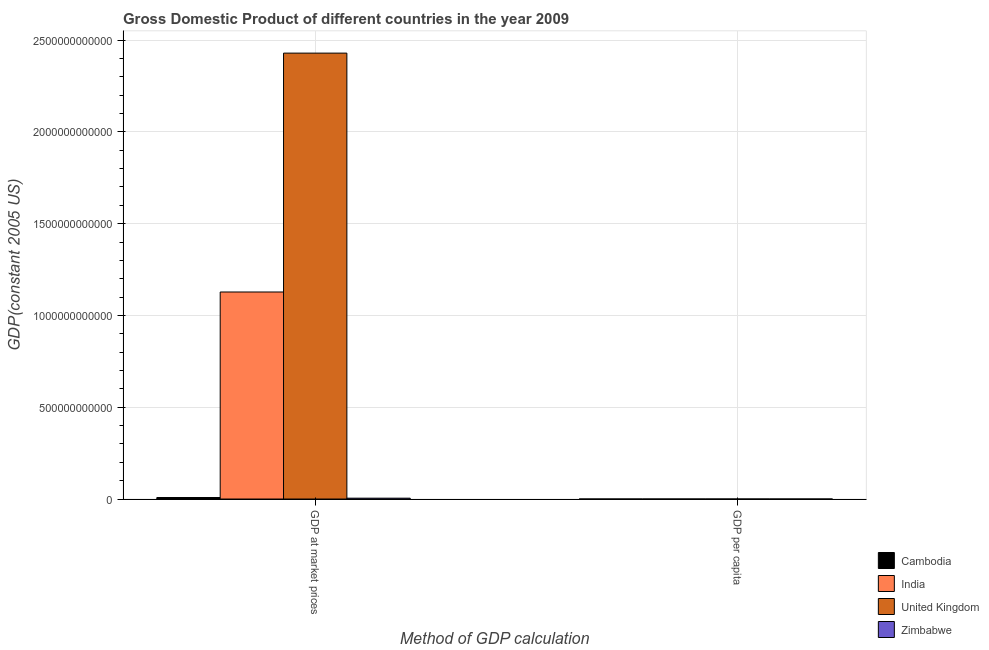How many groups of bars are there?
Your answer should be compact. 2. Are the number of bars on each tick of the X-axis equal?
Your answer should be compact. Yes. How many bars are there on the 1st tick from the right?
Give a very brief answer. 4. What is the label of the 1st group of bars from the left?
Make the answer very short. GDP at market prices. What is the gdp per capita in United Kingdom?
Offer a terse response. 3.90e+04. Across all countries, what is the maximum gdp at market prices?
Offer a very short reply. 2.43e+12. Across all countries, what is the minimum gdp per capita?
Make the answer very short. 340.42. In which country was the gdp at market prices maximum?
Keep it short and to the point. United Kingdom. In which country was the gdp at market prices minimum?
Your answer should be very brief. Zimbabwe. What is the total gdp per capita in the graph?
Your response must be concise. 4.09e+04. What is the difference between the gdp per capita in Cambodia and that in United Kingdom?
Your answer should be compact. -3.84e+04. What is the difference between the gdp per capita in India and the gdp at market prices in Zimbabwe?
Make the answer very short. -4.67e+09. What is the average gdp at market prices per country?
Offer a terse response. 8.93e+11. What is the difference between the gdp at market prices and gdp per capita in Cambodia?
Offer a terse response. 8.20e+09. In how many countries, is the gdp at market prices greater than 2200000000000 US$?
Ensure brevity in your answer.  1. What is the ratio of the gdp per capita in Cambodia to that in United Kingdom?
Provide a succinct answer. 0.01. Is the gdp at market prices in India less than that in Zimbabwe?
Offer a very short reply. No. What does the 2nd bar from the left in GDP per capita represents?
Provide a short and direct response. India. What does the 1st bar from the right in GDP at market prices represents?
Give a very brief answer. Zimbabwe. Are all the bars in the graph horizontal?
Offer a terse response. No. What is the difference between two consecutive major ticks on the Y-axis?
Make the answer very short. 5.00e+11. Are the values on the major ticks of Y-axis written in scientific E-notation?
Give a very brief answer. No. Does the graph contain grids?
Make the answer very short. Yes. Where does the legend appear in the graph?
Ensure brevity in your answer.  Bottom right. What is the title of the graph?
Ensure brevity in your answer.  Gross Domestic Product of different countries in the year 2009. Does "Kuwait" appear as one of the legend labels in the graph?
Make the answer very short. No. What is the label or title of the X-axis?
Provide a short and direct response. Method of GDP calculation. What is the label or title of the Y-axis?
Ensure brevity in your answer.  GDP(constant 2005 US). What is the GDP(constant 2005 US) of Cambodia in GDP at market prices?
Keep it short and to the point. 8.20e+09. What is the GDP(constant 2005 US) in India in GDP at market prices?
Provide a succinct answer. 1.13e+12. What is the GDP(constant 2005 US) in United Kingdom in GDP at market prices?
Provide a short and direct response. 2.43e+12. What is the GDP(constant 2005 US) in Zimbabwe in GDP at market prices?
Your answer should be very brief. 4.67e+09. What is the GDP(constant 2005 US) in Cambodia in GDP per capita?
Provide a succinct answer. 580.02. What is the GDP(constant 2005 US) of India in GDP per capita?
Ensure brevity in your answer.  928.98. What is the GDP(constant 2005 US) in United Kingdom in GDP per capita?
Your answer should be very brief. 3.90e+04. What is the GDP(constant 2005 US) of Zimbabwe in GDP per capita?
Keep it short and to the point. 340.42. Across all Method of GDP calculation, what is the maximum GDP(constant 2005 US) of Cambodia?
Give a very brief answer. 8.20e+09. Across all Method of GDP calculation, what is the maximum GDP(constant 2005 US) in India?
Offer a very short reply. 1.13e+12. Across all Method of GDP calculation, what is the maximum GDP(constant 2005 US) of United Kingdom?
Offer a very short reply. 2.43e+12. Across all Method of GDP calculation, what is the maximum GDP(constant 2005 US) of Zimbabwe?
Provide a succinct answer. 4.67e+09. Across all Method of GDP calculation, what is the minimum GDP(constant 2005 US) in Cambodia?
Provide a short and direct response. 580.02. Across all Method of GDP calculation, what is the minimum GDP(constant 2005 US) of India?
Your answer should be very brief. 928.98. Across all Method of GDP calculation, what is the minimum GDP(constant 2005 US) of United Kingdom?
Keep it short and to the point. 3.90e+04. Across all Method of GDP calculation, what is the minimum GDP(constant 2005 US) in Zimbabwe?
Your answer should be very brief. 340.42. What is the total GDP(constant 2005 US) in Cambodia in the graph?
Your response must be concise. 8.20e+09. What is the total GDP(constant 2005 US) of India in the graph?
Offer a very short reply. 1.13e+12. What is the total GDP(constant 2005 US) of United Kingdom in the graph?
Provide a succinct answer. 2.43e+12. What is the total GDP(constant 2005 US) in Zimbabwe in the graph?
Offer a very short reply. 4.67e+09. What is the difference between the GDP(constant 2005 US) in Cambodia in GDP at market prices and that in GDP per capita?
Ensure brevity in your answer.  8.20e+09. What is the difference between the GDP(constant 2005 US) in India in GDP at market prices and that in GDP per capita?
Offer a terse response. 1.13e+12. What is the difference between the GDP(constant 2005 US) of United Kingdom in GDP at market prices and that in GDP per capita?
Offer a very short reply. 2.43e+12. What is the difference between the GDP(constant 2005 US) in Zimbabwe in GDP at market prices and that in GDP per capita?
Your answer should be compact. 4.67e+09. What is the difference between the GDP(constant 2005 US) of Cambodia in GDP at market prices and the GDP(constant 2005 US) of India in GDP per capita?
Make the answer very short. 8.20e+09. What is the difference between the GDP(constant 2005 US) in Cambodia in GDP at market prices and the GDP(constant 2005 US) in United Kingdom in GDP per capita?
Make the answer very short. 8.20e+09. What is the difference between the GDP(constant 2005 US) in Cambodia in GDP at market prices and the GDP(constant 2005 US) in Zimbabwe in GDP per capita?
Keep it short and to the point. 8.20e+09. What is the difference between the GDP(constant 2005 US) in India in GDP at market prices and the GDP(constant 2005 US) in United Kingdom in GDP per capita?
Ensure brevity in your answer.  1.13e+12. What is the difference between the GDP(constant 2005 US) in India in GDP at market prices and the GDP(constant 2005 US) in Zimbabwe in GDP per capita?
Your answer should be compact. 1.13e+12. What is the difference between the GDP(constant 2005 US) in United Kingdom in GDP at market prices and the GDP(constant 2005 US) in Zimbabwe in GDP per capita?
Your answer should be compact. 2.43e+12. What is the average GDP(constant 2005 US) of Cambodia per Method of GDP calculation?
Keep it short and to the point. 4.10e+09. What is the average GDP(constant 2005 US) in India per Method of GDP calculation?
Provide a succinct answer. 5.64e+11. What is the average GDP(constant 2005 US) in United Kingdom per Method of GDP calculation?
Provide a short and direct response. 1.21e+12. What is the average GDP(constant 2005 US) of Zimbabwe per Method of GDP calculation?
Keep it short and to the point. 2.34e+09. What is the difference between the GDP(constant 2005 US) in Cambodia and GDP(constant 2005 US) in India in GDP at market prices?
Make the answer very short. -1.12e+12. What is the difference between the GDP(constant 2005 US) in Cambodia and GDP(constant 2005 US) in United Kingdom in GDP at market prices?
Ensure brevity in your answer.  -2.42e+12. What is the difference between the GDP(constant 2005 US) in Cambodia and GDP(constant 2005 US) in Zimbabwe in GDP at market prices?
Provide a short and direct response. 3.53e+09. What is the difference between the GDP(constant 2005 US) in India and GDP(constant 2005 US) in United Kingdom in GDP at market prices?
Your answer should be compact. -1.30e+12. What is the difference between the GDP(constant 2005 US) of India and GDP(constant 2005 US) of Zimbabwe in GDP at market prices?
Offer a very short reply. 1.12e+12. What is the difference between the GDP(constant 2005 US) of United Kingdom and GDP(constant 2005 US) of Zimbabwe in GDP at market prices?
Your answer should be very brief. 2.42e+12. What is the difference between the GDP(constant 2005 US) of Cambodia and GDP(constant 2005 US) of India in GDP per capita?
Offer a terse response. -348.96. What is the difference between the GDP(constant 2005 US) of Cambodia and GDP(constant 2005 US) of United Kingdom in GDP per capita?
Keep it short and to the point. -3.84e+04. What is the difference between the GDP(constant 2005 US) in Cambodia and GDP(constant 2005 US) in Zimbabwe in GDP per capita?
Offer a very short reply. 239.6. What is the difference between the GDP(constant 2005 US) in India and GDP(constant 2005 US) in United Kingdom in GDP per capita?
Provide a short and direct response. -3.81e+04. What is the difference between the GDP(constant 2005 US) of India and GDP(constant 2005 US) of Zimbabwe in GDP per capita?
Your answer should be compact. 588.55. What is the difference between the GDP(constant 2005 US) in United Kingdom and GDP(constant 2005 US) in Zimbabwe in GDP per capita?
Offer a terse response. 3.87e+04. What is the ratio of the GDP(constant 2005 US) in Cambodia in GDP at market prices to that in GDP per capita?
Ensure brevity in your answer.  1.41e+07. What is the ratio of the GDP(constant 2005 US) in India in GDP at market prices to that in GDP per capita?
Give a very brief answer. 1.21e+09. What is the ratio of the GDP(constant 2005 US) of United Kingdom in GDP at market prices to that in GDP per capita?
Give a very brief answer. 6.23e+07. What is the ratio of the GDP(constant 2005 US) in Zimbabwe in GDP at market prices to that in GDP per capita?
Keep it short and to the point. 1.37e+07. What is the difference between the highest and the second highest GDP(constant 2005 US) of Cambodia?
Your response must be concise. 8.20e+09. What is the difference between the highest and the second highest GDP(constant 2005 US) of India?
Make the answer very short. 1.13e+12. What is the difference between the highest and the second highest GDP(constant 2005 US) in United Kingdom?
Keep it short and to the point. 2.43e+12. What is the difference between the highest and the second highest GDP(constant 2005 US) in Zimbabwe?
Your response must be concise. 4.67e+09. What is the difference between the highest and the lowest GDP(constant 2005 US) in Cambodia?
Ensure brevity in your answer.  8.20e+09. What is the difference between the highest and the lowest GDP(constant 2005 US) of India?
Ensure brevity in your answer.  1.13e+12. What is the difference between the highest and the lowest GDP(constant 2005 US) of United Kingdom?
Make the answer very short. 2.43e+12. What is the difference between the highest and the lowest GDP(constant 2005 US) in Zimbabwe?
Ensure brevity in your answer.  4.67e+09. 